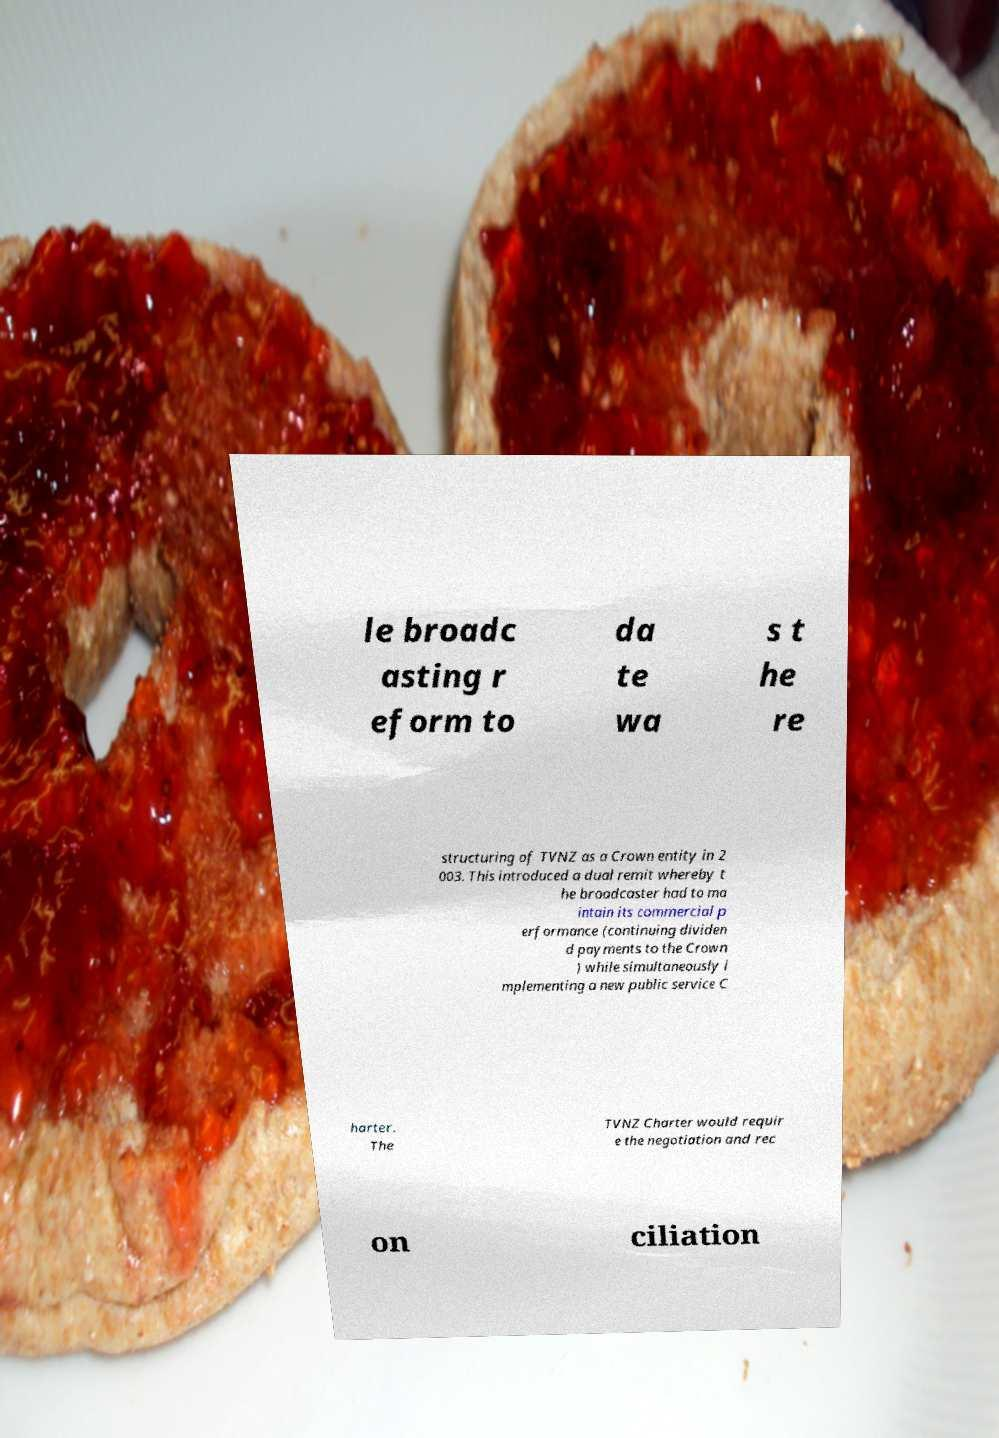Please identify and transcribe the text found in this image. le broadc asting r eform to da te wa s t he re structuring of TVNZ as a Crown entity in 2 003. This introduced a dual remit whereby t he broadcaster had to ma intain its commercial p erformance (continuing dividen d payments to the Crown ) while simultaneously i mplementing a new public service C harter. The TVNZ Charter would requir e the negotiation and rec on ciliation 